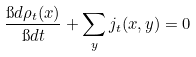Convert formula to latex. <formula><loc_0><loc_0><loc_500><loc_500>\frac { \i d \rho _ { t } ( x ) } { \i d t } + \sum _ { y } j _ { t } ( x , y ) = 0</formula> 